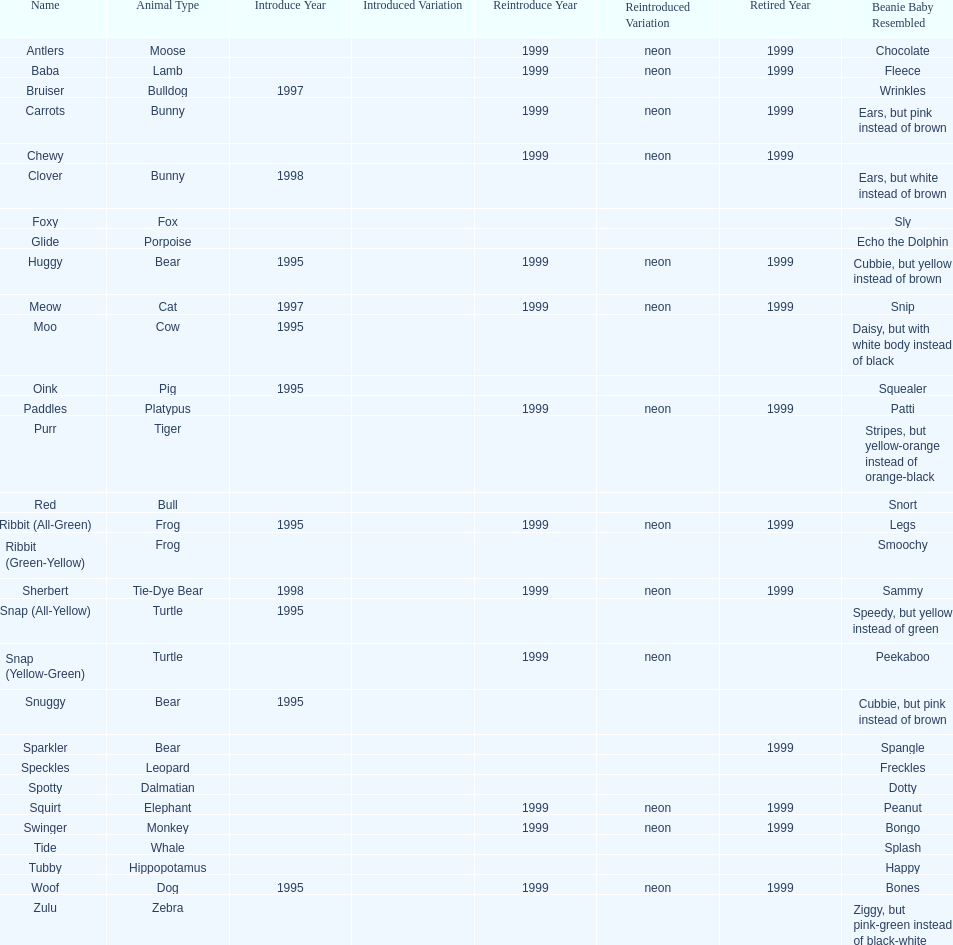What are the total number of pillow pals on this chart? 30. 